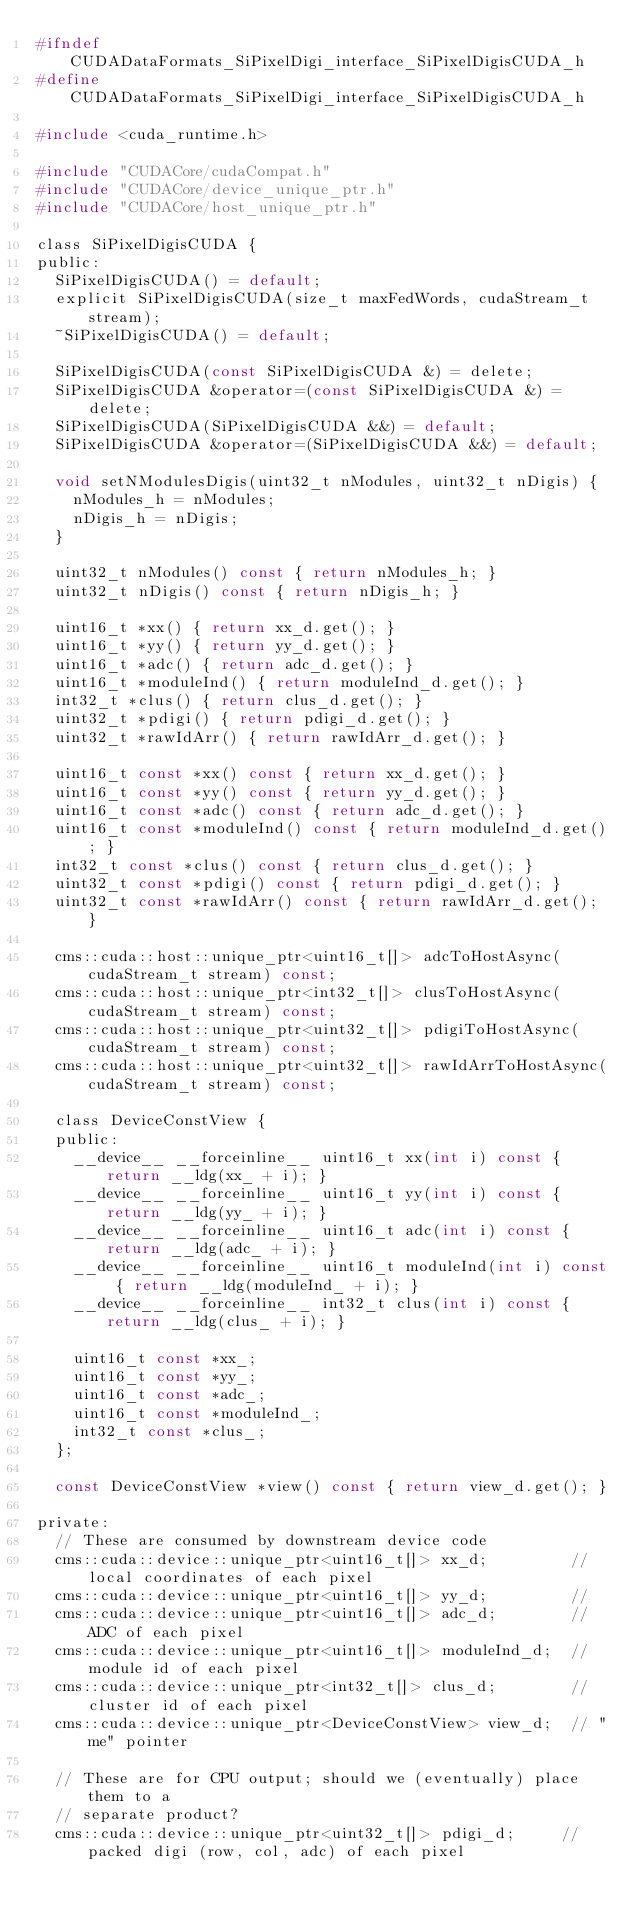Convert code to text. <code><loc_0><loc_0><loc_500><loc_500><_C_>#ifndef CUDADataFormats_SiPixelDigi_interface_SiPixelDigisCUDA_h
#define CUDADataFormats_SiPixelDigi_interface_SiPixelDigisCUDA_h

#include <cuda_runtime.h>

#include "CUDACore/cudaCompat.h"
#include "CUDACore/device_unique_ptr.h"
#include "CUDACore/host_unique_ptr.h"

class SiPixelDigisCUDA {
public:
  SiPixelDigisCUDA() = default;
  explicit SiPixelDigisCUDA(size_t maxFedWords, cudaStream_t stream);
  ~SiPixelDigisCUDA() = default;

  SiPixelDigisCUDA(const SiPixelDigisCUDA &) = delete;
  SiPixelDigisCUDA &operator=(const SiPixelDigisCUDA &) = delete;
  SiPixelDigisCUDA(SiPixelDigisCUDA &&) = default;
  SiPixelDigisCUDA &operator=(SiPixelDigisCUDA &&) = default;

  void setNModulesDigis(uint32_t nModules, uint32_t nDigis) {
    nModules_h = nModules;
    nDigis_h = nDigis;
  }

  uint32_t nModules() const { return nModules_h; }
  uint32_t nDigis() const { return nDigis_h; }

  uint16_t *xx() { return xx_d.get(); }
  uint16_t *yy() { return yy_d.get(); }
  uint16_t *adc() { return adc_d.get(); }
  uint16_t *moduleInd() { return moduleInd_d.get(); }
  int32_t *clus() { return clus_d.get(); }
  uint32_t *pdigi() { return pdigi_d.get(); }
  uint32_t *rawIdArr() { return rawIdArr_d.get(); }

  uint16_t const *xx() const { return xx_d.get(); }
  uint16_t const *yy() const { return yy_d.get(); }
  uint16_t const *adc() const { return adc_d.get(); }
  uint16_t const *moduleInd() const { return moduleInd_d.get(); }
  int32_t const *clus() const { return clus_d.get(); }
  uint32_t const *pdigi() const { return pdigi_d.get(); }
  uint32_t const *rawIdArr() const { return rawIdArr_d.get(); }

  cms::cuda::host::unique_ptr<uint16_t[]> adcToHostAsync(cudaStream_t stream) const;
  cms::cuda::host::unique_ptr<int32_t[]> clusToHostAsync(cudaStream_t stream) const;
  cms::cuda::host::unique_ptr<uint32_t[]> pdigiToHostAsync(cudaStream_t stream) const;
  cms::cuda::host::unique_ptr<uint32_t[]> rawIdArrToHostAsync(cudaStream_t stream) const;

  class DeviceConstView {
  public:
    __device__ __forceinline__ uint16_t xx(int i) const { return __ldg(xx_ + i); }
    __device__ __forceinline__ uint16_t yy(int i) const { return __ldg(yy_ + i); }
    __device__ __forceinline__ uint16_t adc(int i) const { return __ldg(adc_ + i); }
    __device__ __forceinline__ uint16_t moduleInd(int i) const { return __ldg(moduleInd_ + i); }
    __device__ __forceinline__ int32_t clus(int i) const { return __ldg(clus_ + i); }

    uint16_t const *xx_;
    uint16_t const *yy_;
    uint16_t const *adc_;
    uint16_t const *moduleInd_;
    int32_t const *clus_;
  };

  const DeviceConstView *view() const { return view_d.get(); }

private:
  // These are consumed by downstream device code
  cms::cuda::device::unique_ptr<uint16_t[]> xx_d;         // local coordinates of each pixel
  cms::cuda::device::unique_ptr<uint16_t[]> yy_d;         //
  cms::cuda::device::unique_ptr<uint16_t[]> adc_d;        // ADC of each pixel
  cms::cuda::device::unique_ptr<uint16_t[]> moduleInd_d;  // module id of each pixel
  cms::cuda::device::unique_ptr<int32_t[]> clus_d;        // cluster id of each pixel
  cms::cuda::device::unique_ptr<DeviceConstView> view_d;  // "me" pointer

  // These are for CPU output; should we (eventually) place them to a
  // separate product?
  cms::cuda::device::unique_ptr<uint32_t[]> pdigi_d;     // packed digi (row, col, adc) of each pixel</code> 